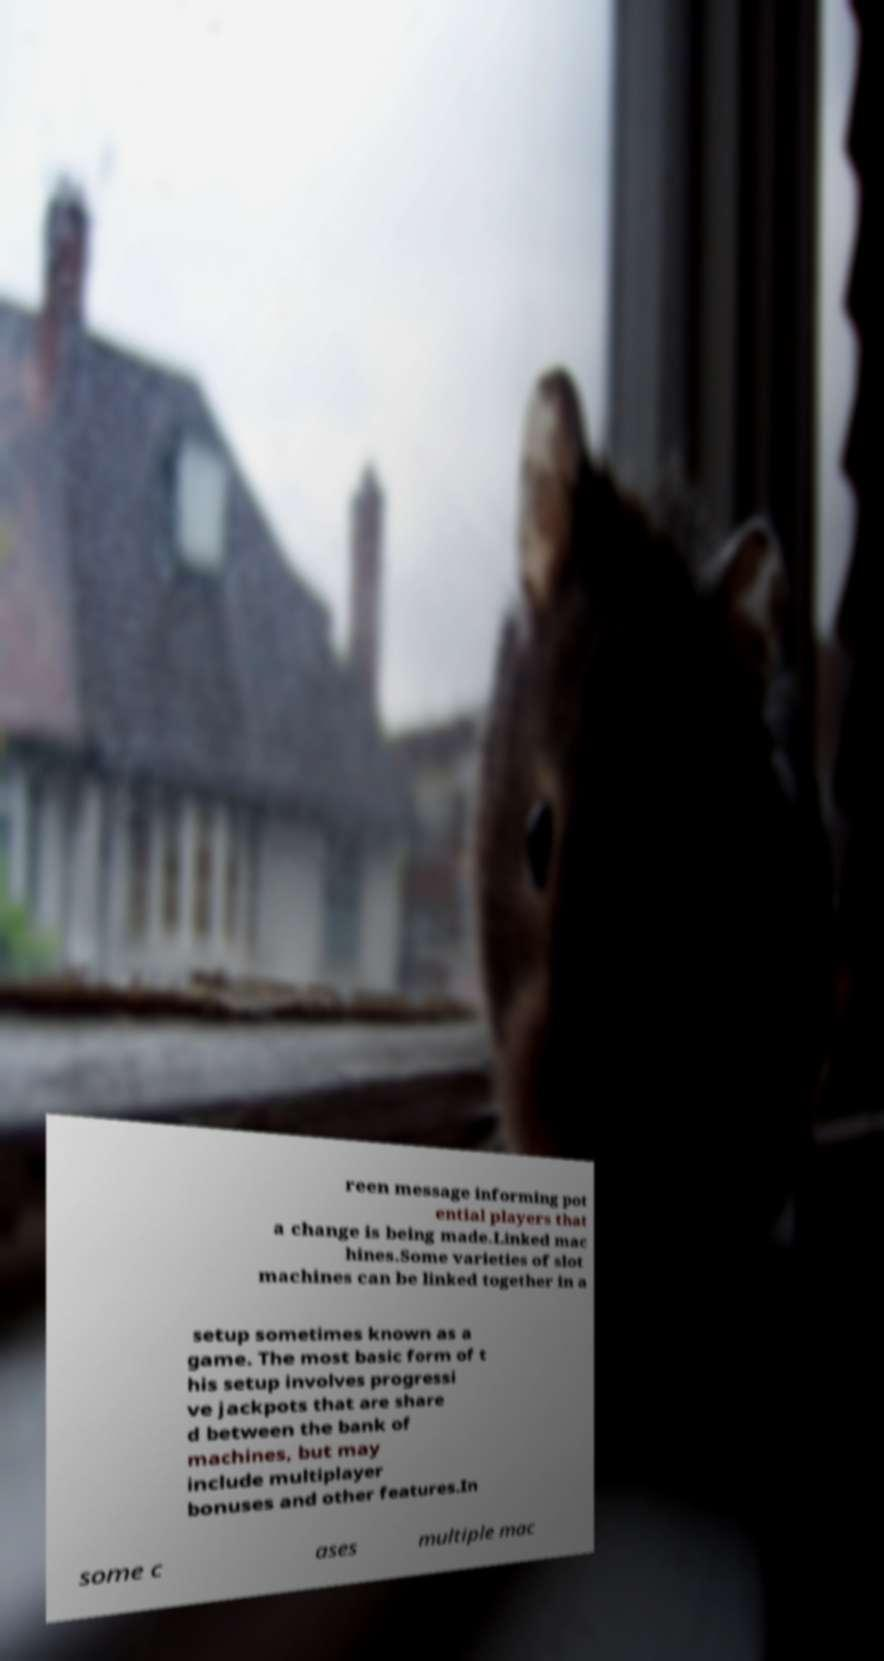For documentation purposes, I need the text within this image transcribed. Could you provide that? reen message informing pot ential players that a change is being made.Linked mac hines.Some varieties of slot machines can be linked together in a setup sometimes known as a game. The most basic form of t his setup involves progressi ve jackpots that are share d between the bank of machines, but may include multiplayer bonuses and other features.In some c ases multiple mac 